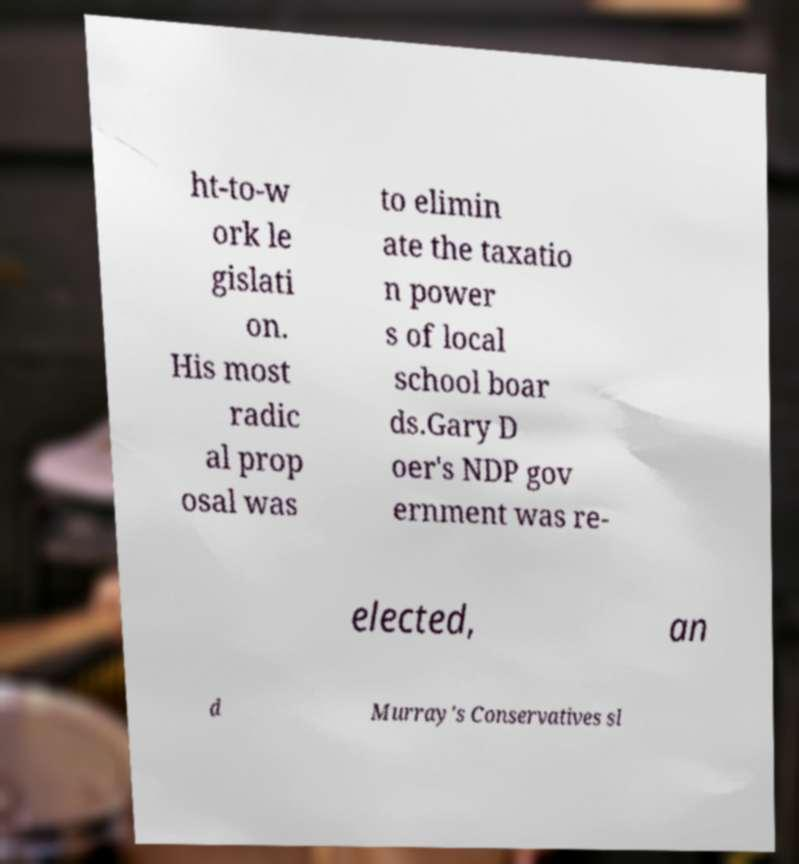There's text embedded in this image that I need extracted. Can you transcribe it verbatim? ht-to-w ork le gislati on. His most radic al prop osal was to elimin ate the taxatio n power s of local school boar ds.Gary D oer's NDP gov ernment was re- elected, an d Murray's Conservatives sl 